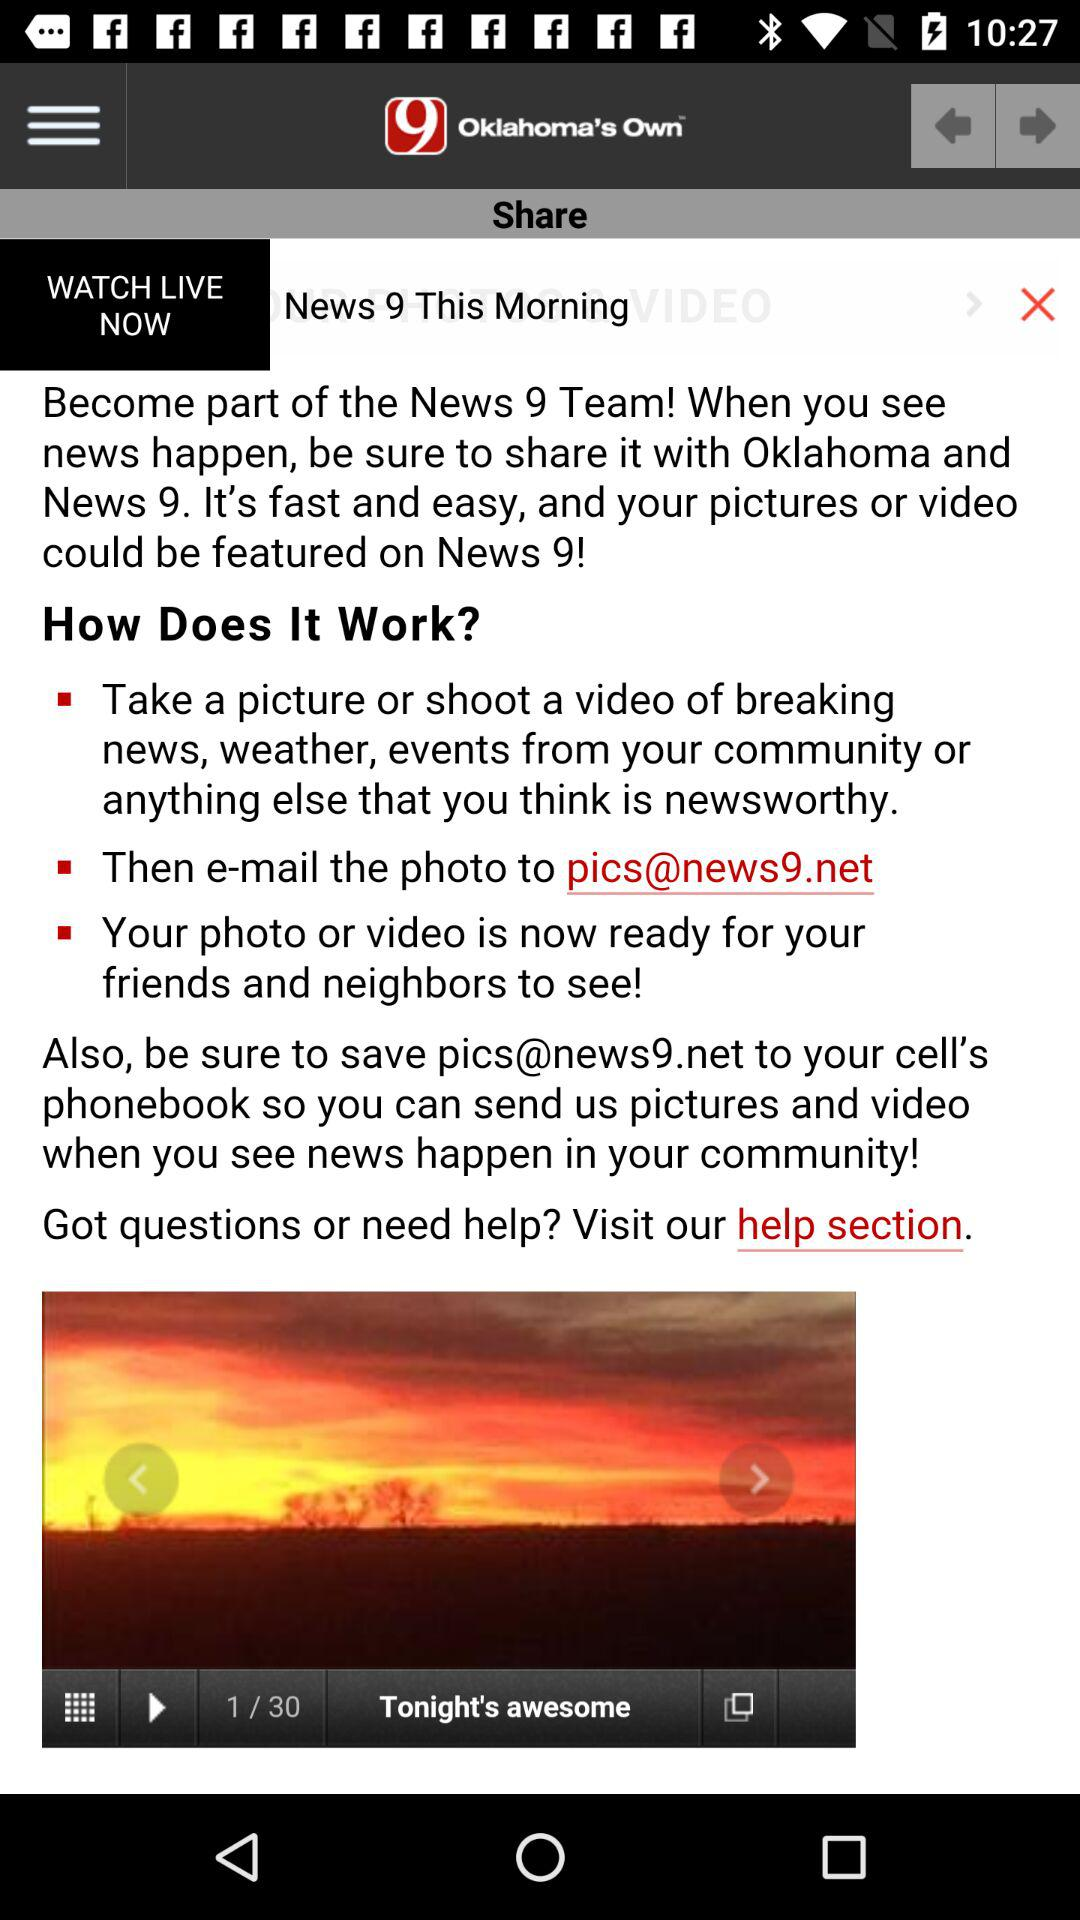How many videos in total are in the list? There are a total of 30 videos. 